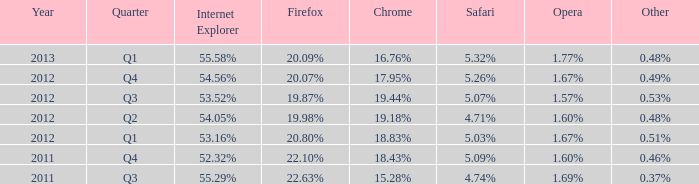What opera has 19.87% as the firefox? 1.57%. 